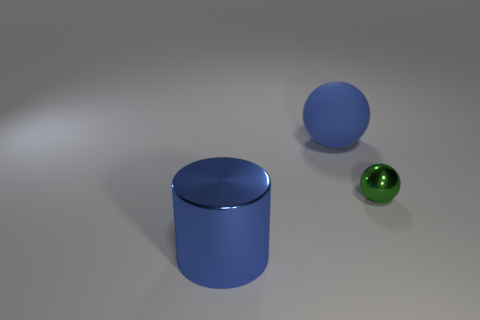Add 2 large yellow blocks. How many objects exist? 5 Subtract 1 spheres. How many spheres are left? 1 Subtract all blue balls. How many balls are left? 1 Subtract all balls. How many objects are left? 1 Subtract all red cylinders. Subtract all brown spheres. How many cylinders are left? 1 Subtract all green cubes. How many green balls are left? 1 Subtract all small green balls. Subtract all large blue metal cylinders. How many objects are left? 1 Add 3 blue rubber objects. How many blue rubber objects are left? 4 Add 1 blue matte cylinders. How many blue matte cylinders exist? 1 Subtract 0 cyan blocks. How many objects are left? 3 